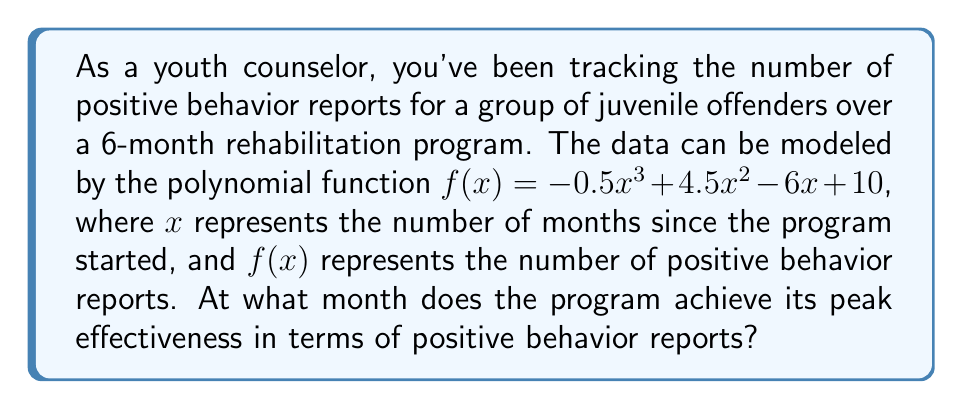Can you solve this math problem? To find the month when the program achieves its peak effectiveness, we need to determine the maximum point of the polynomial function. This can be done by following these steps:

1) First, we need to find the derivative of the function:
   $f'(x) = -1.5x^2 + 9x - 6$

2) To find the critical points, set $f'(x) = 0$ and solve for $x$:
   $-1.5x^2 + 9x - 6 = 0$

3) This is a quadratic equation. We can solve it using the quadratic formula:
   $x = \frac{-b \pm \sqrt{b^2 - 4ac}}{2a}$

   Where $a = -1.5$, $b = 9$, and $c = -6$

4) Plugging these values into the quadratic formula:
   $x = \frac{-9 \pm \sqrt{81 - 4(-1.5)(-6)}}{2(-1.5)}$
   $= \frac{-9 \pm \sqrt{81 - 36}}{-3}$
   $= \frac{-9 \pm \sqrt{45}}{-3}$
   $= \frac{-9 \pm 6.71}{-3}$

5) This gives us two solutions:
   $x_1 = \frac{-9 + 6.71}{-3} = 0.76$
   $x_2 = \frac{-9 - 6.71}{-3} = 5.24$

6) To determine which of these is the maximum, we can check the second derivative:
   $f''(x) = -3x + 9$

   At $x = 0.76$, $f''(0.76) = -3(0.76) + 9 = 6.72 > 0$, indicating a minimum.
   At $x = 5.24$, $f''(5.24) = -3(5.24) + 9 = -6.72 < 0$, indicating a maximum.

Therefore, the program achieves its peak effectiveness at $x = 5.24$ months, which rounds to 5 months.
Answer: 5 months 